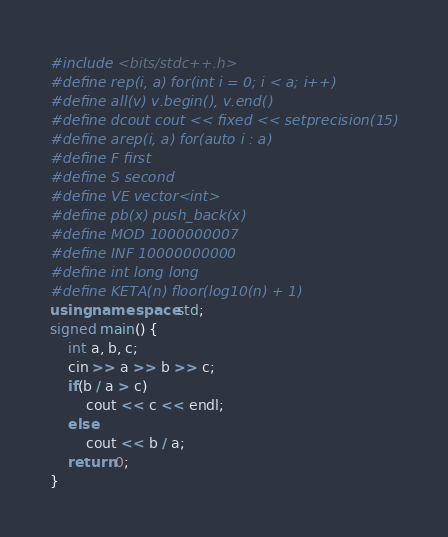Convert code to text. <code><loc_0><loc_0><loc_500><loc_500><_C++_>#include <bits/stdc++.h>
#define rep(i, a) for(int i = 0; i < a; i++)
#define all(v) v.begin(), v.end()
#define dcout cout << fixed << setprecision(15)
#define arep(i, a) for(auto i : a)
#define F first
#define S second
#define VE vector<int>
#define pb(x) push_back(x)
#define MOD 1000000007
#define INF 10000000000
#define int long long
#define KETA(n) floor(log10(n) + 1)
using namespace std;
signed main() {
    int a, b, c;
    cin >> a >> b >> c;
    if(b / a > c)
        cout << c << endl;
    else
        cout << b / a;
    return 0;
}</code> 